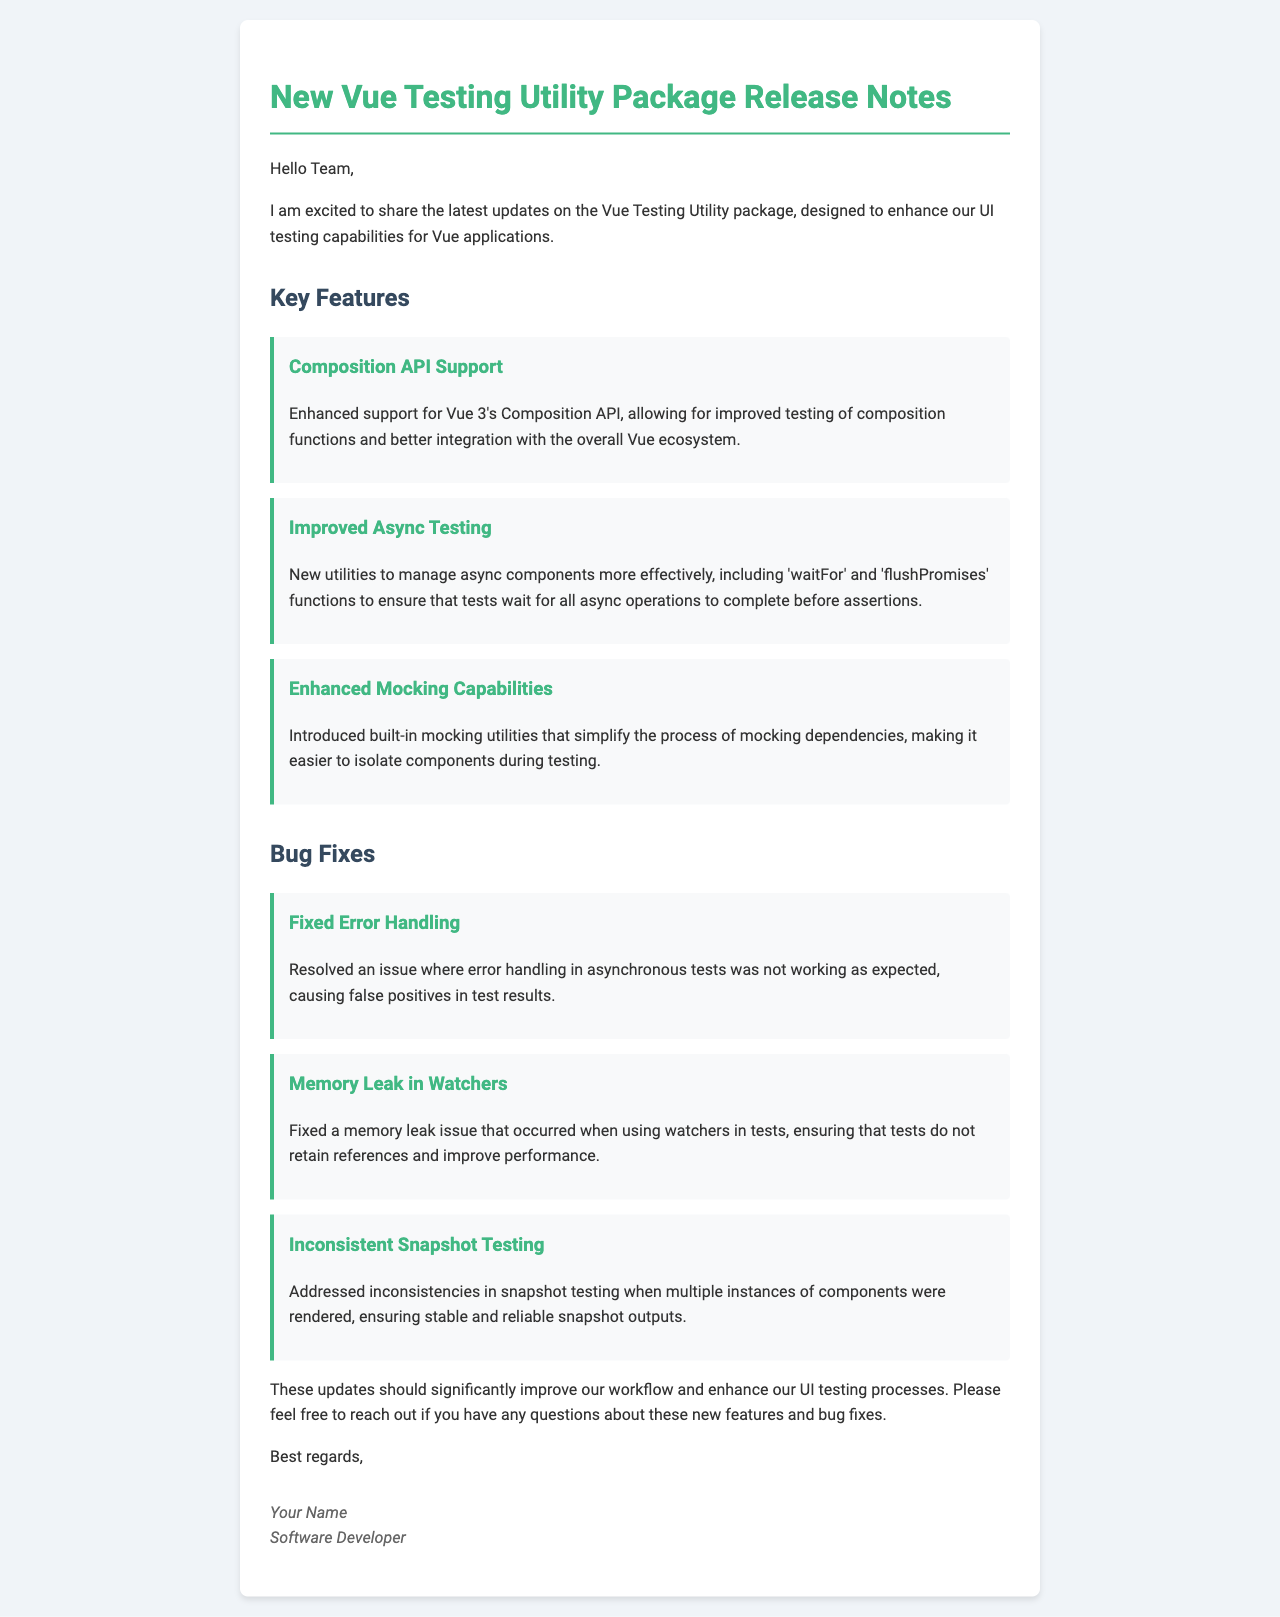What is the title of the document? The title of the document is displayed in the header and indicates the content of the mail.
Answer: New Vue Testing Utility Package Release Notes What is one of the key features mentioned? The document lists several key features, highlighting improvements and enhancements in the Vue Testing Utility package.
Answer: Composition API Support What function is introduced for managing async components? The document mentions specific utility functions designed to improve async testing capabilities.
Answer: waitFor What bug was fixed related to asynchronous tests? The document specifies a bug fix that addresses error handling issues in a specific context.
Answer: Fixed Error Handling How many bug fixes are listed in the document? The document enumerates specific bug fixes, revealing the number of issues that were addressed.
Answer: Three What is the email salutation? The salutation is a greeting used to address the team in the opening of the email.
Answer: Hello Team Who signed the document? The signature at the end of the document identifies the author of the email.
Answer: Your Name What issue is resolved regarding watchers? The document details specific problems that were fixed, particularly those concerning performance.
Answer: Memory Leak in Watchers What is the color scheme of the headings? The document uses a specific color to enhance readability and visual appeal in headings.
Answer: #41b883 